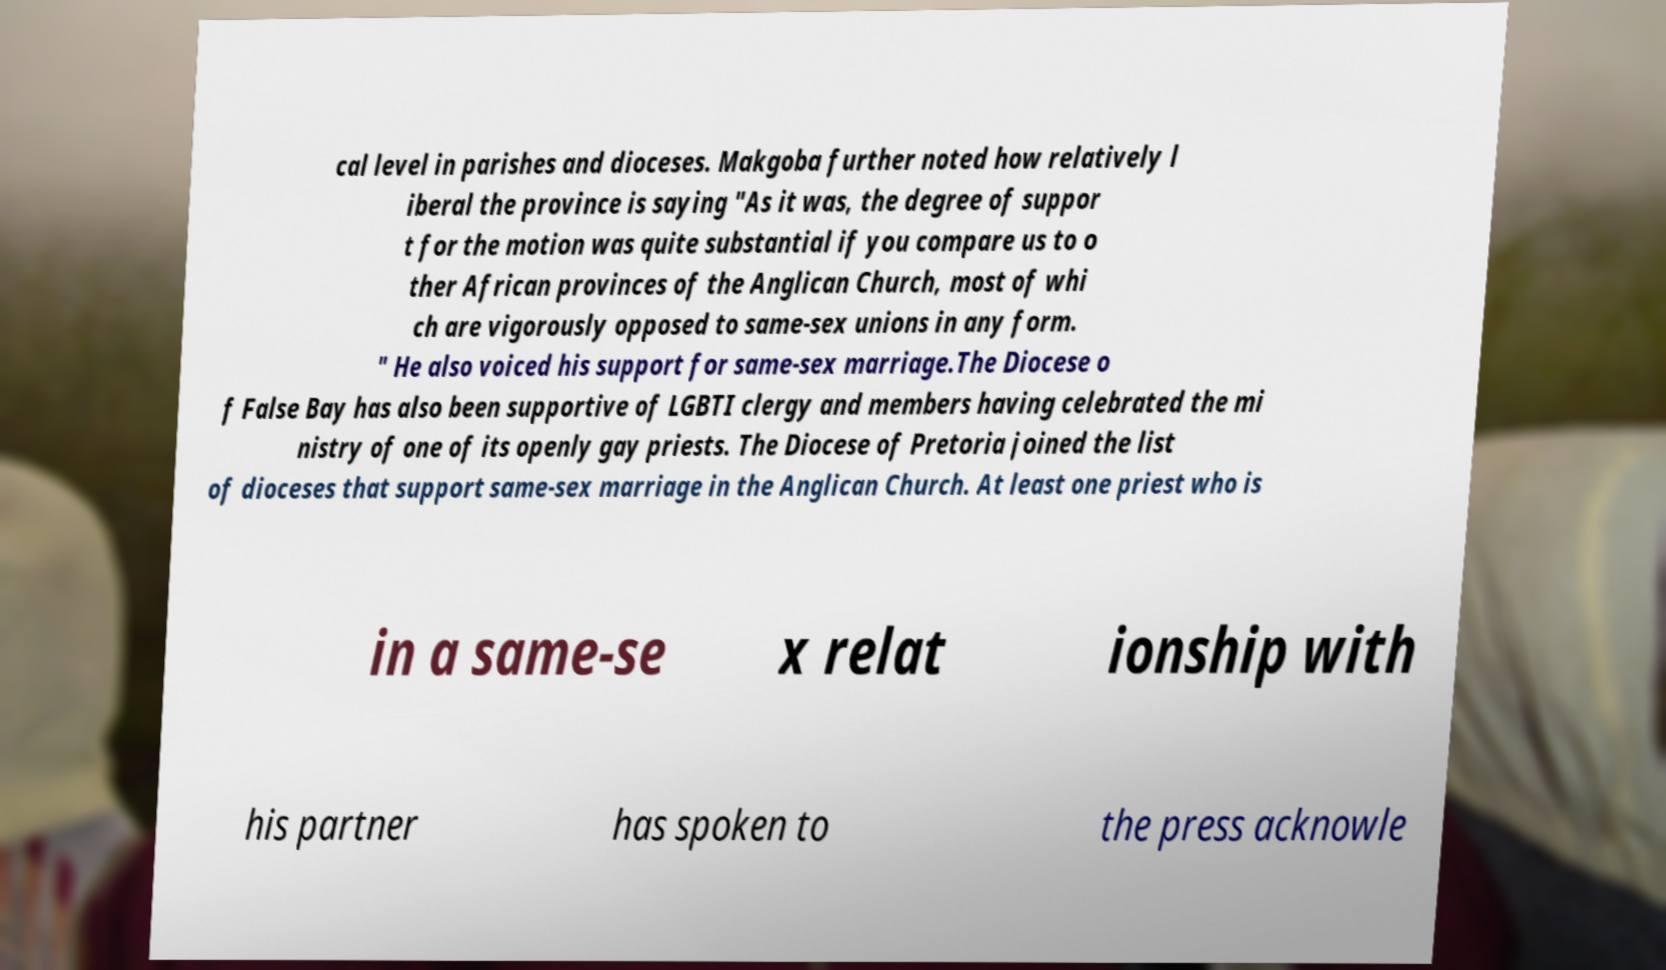For documentation purposes, I need the text within this image transcribed. Could you provide that? cal level in parishes and dioceses. Makgoba further noted how relatively l iberal the province is saying "As it was, the degree of suppor t for the motion was quite substantial if you compare us to o ther African provinces of the Anglican Church, most of whi ch are vigorously opposed to same-sex unions in any form. " He also voiced his support for same-sex marriage.The Diocese o f False Bay has also been supportive of LGBTI clergy and members having celebrated the mi nistry of one of its openly gay priests. The Diocese of Pretoria joined the list of dioceses that support same-sex marriage in the Anglican Church. At least one priest who is in a same-se x relat ionship with his partner has spoken to the press acknowle 